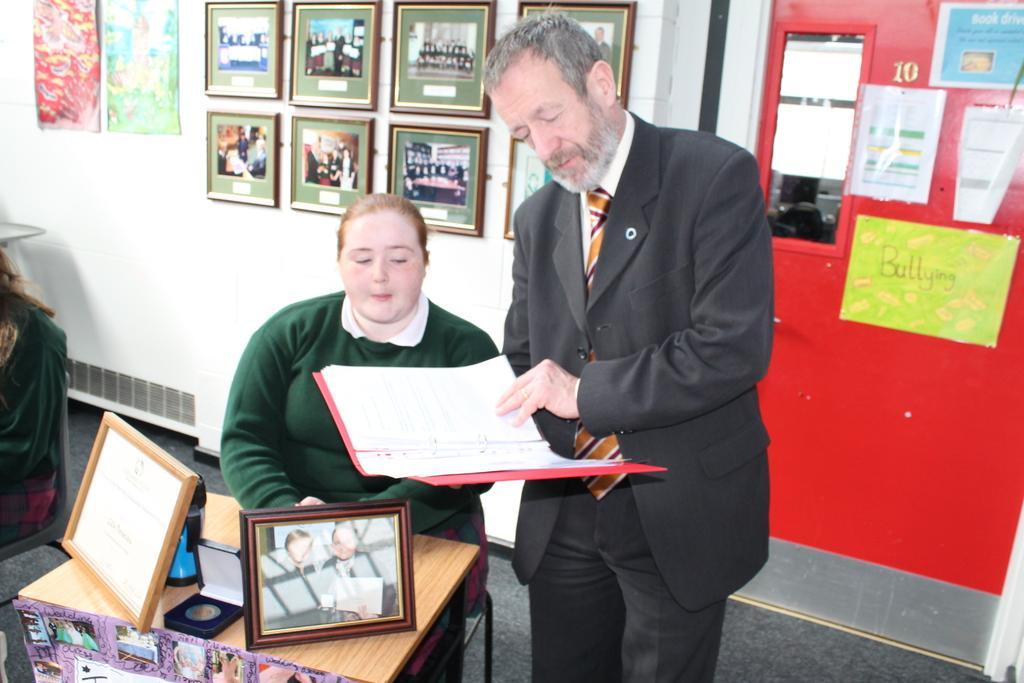Describe this image in one or two sentences. In this picture we can see a woman is sitting on a chair and a man in the black blazer is standing on the floor and holding a file. In front of the woman there is a table and on the table there are photo frames and other things. Behind the people there is a wall with photo frames and poster. 